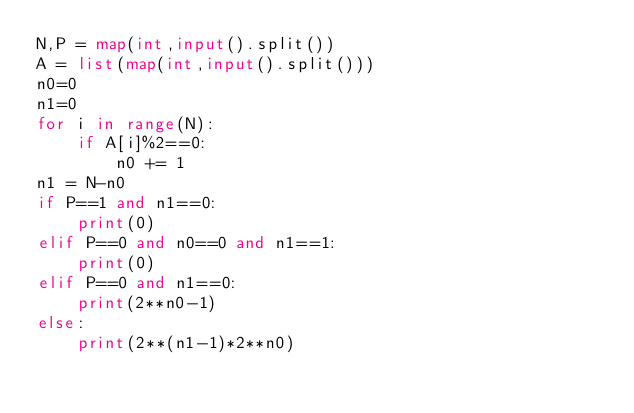Convert code to text. <code><loc_0><loc_0><loc_500><loc_500><_Python_>N,P = map(int,input().split())
A = list(map(int,input().split()))
n0=0
n1=0
for i in range(N):
    if A[i]%2==0:
        n0 += 1
n1 = N-n0
if P==1 and n1==0:
    print(0)
elif P==0 and n0==0 and n1==1:
    print(0)
elif P==0 and n1==0:
    print(2**n0-1)
else:
    print(2**(n1-1)*2**n0)</code> 